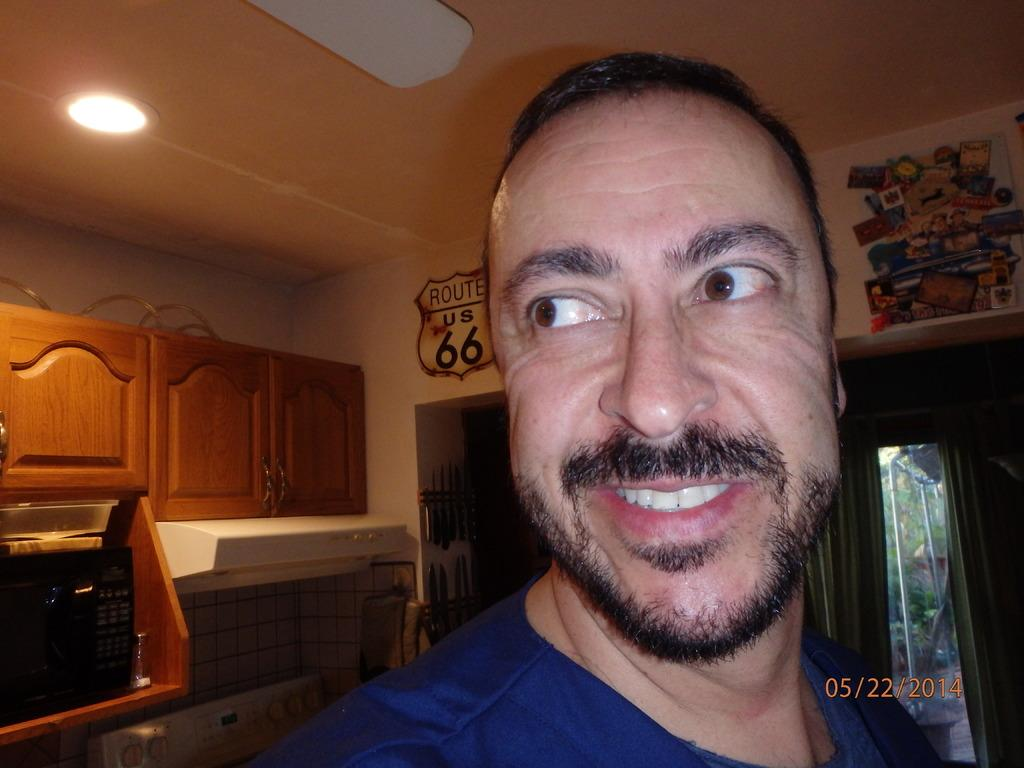Who is present in the image? There is a man in the image. What is the man's facial expression? The man is smiling. What can be seen in the background of the image? There are cupboards, a microwave oven, a jar, the ceiling, a light, posters, poles, trees, knives, walls, and some unspecified objects in the background of the image. What is the profit margin of the unspecified objects in the image? There is no information about profit margins in the image, as it focuses on the man and the objects in the background. --- Facts: 1. There is a car in the image. 2. The car is red. 3. The car has four wheels. 4. There are people in the car. 5. The car is parked on the street. 6. There are trees on the side of the street. 7. The sky is visible in the image. Absurd Topics: dance, ocean, volcano Conversation: What is the main subject of the image? The main subject of the image is a car. What color is the car? The car is red. How many wheels does the car have? The car has four wheels. Who is inside the car? There are people in the car. Where is the car located? The car is parked on the street. What can be seen on the side of the street? There are trees on the side of the street. What is visible in the background of the image? The sky is visible in the image. Reasoning: Let's think step by step in order to produce the conversation. We start by identifying the main subject in the image, which is the car. Then, we describe the car's color and the number of wheels it has. Next, we mention the people inside the car and its location on the street. We also describe the trees on the side of the street and the sky visible in the background. Each question is designed to elicit a specific detail about the image that is known from the provided facts. Absurd Question/Answer: Can you see any ocean or volcano in the image? No, there is no ocean or volcano present in the image. 